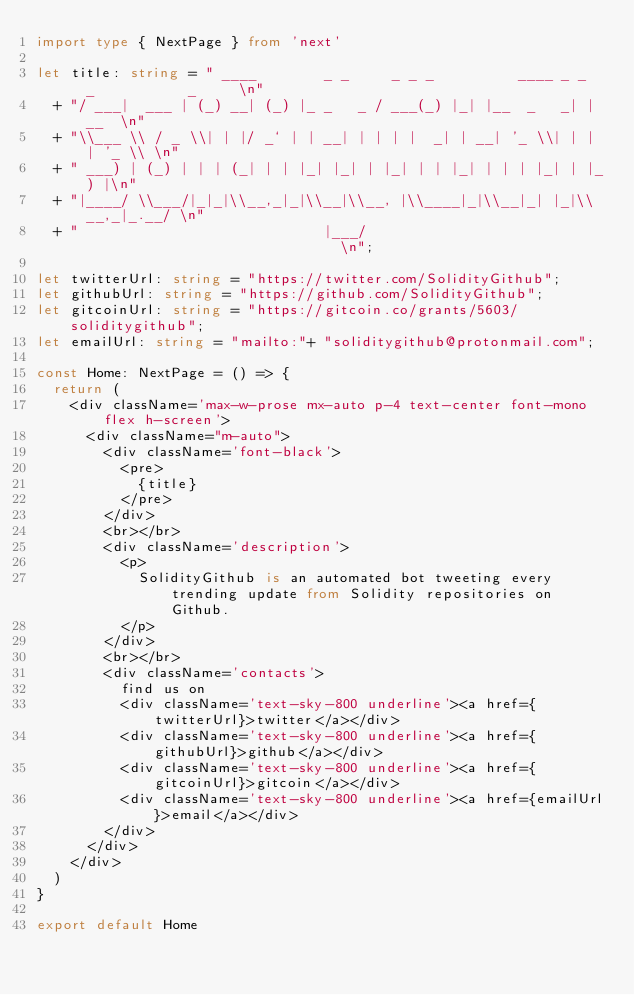<code> <loc_0><loc_0><loc_500><loc_500><_TypeScript_>import type { NextPage } from 'next'

let title: string = " ____        _ _     _ _ _          ____ _ _   _           _     \n"
  + "/ ___|  ___ | (_) __| (_) |_ _   _ / ___(_) |_| |__  _   _| |__  \n"
  + "\\___ \\ / _ \\| | |/ _` | | __| | | | |  _| | __| '_ \\| | | | '_ \\ \n"
  + " ___) | (_) | | | (_| | | |_| |_| | |_| | | |_| | | | |_| | |_) |\n"
  + "|____/ \\___/|_|_|\\__,_|_|\\__|\\__, |\\____|_|\\__|_| |_|\\__,_|_.__/ \n"
  + "                             |___/                               \n";

let twitterUrl: string = "https://twitter.com/SolidityGithub";
let githubUrl: string = "https://github.com/SolidityGithub";
let gitcoinUrl: string = "https://gitcoin.co/grants/5603/soliditygithub";
let emailUrl: string = "mailto:"+ "soliditygithub@protonmail.com";

const Home: NextPage = () => {
  return (
    <div className='max-w-prose mx-auto p-4 text-center font-mono flex h-screen'>
      <div className="m-auto">
        <div className='font-black'>
          <pre>
            {title}
          </pre>
        </div>
        <br></br>
        <div className='description'>
          <p>
            SolidityGithub is an automated bot tweeting every trending update from Solidity repositories on Github.
          </p>
        </div>
        <br></br>
        <div className='contacts'>
          find us on
          <div className='text-sky-800 underline'><a href={twitterUrl}>twitter</a></div>
          <div className='text-sky-800 underline'><a href={githubUrl}>github</a></div>
          <div className='text-sky-800 underline'><a href={gitcoinUrl}>gitcoin</a></div>
          <div className='text-sky-800 underline'><a href={emailUrl}>email</a></div>
        </div>
      </div>
    </div>
  )
}

export default Home
</code> 